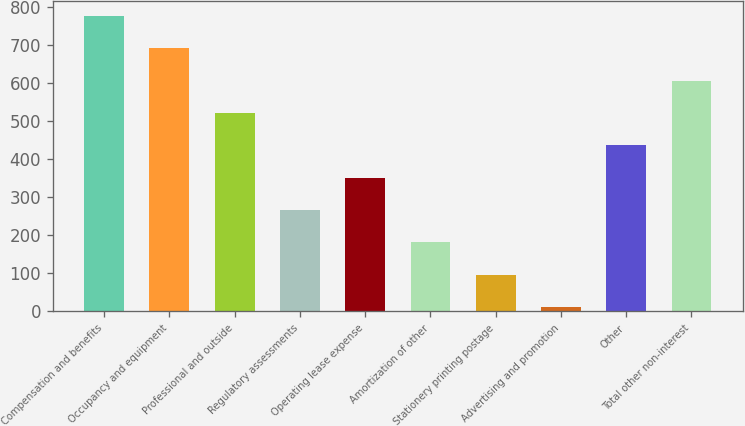Convert chart. <chart><loc_0><loc_0><loc_500><loc_500><bar_chart><fcel>Compensation and benefits<fcel>Occupancy and equipment<fcel>Professional and outside<fcel>Regulatory assessments<fcel>Operating lease expense<fcel>Amortization of other<fcel>Stationery printing postage<fcel>Advertising and promotion<fcel>Other<fcel>Total other non-interest<nl><fcel>775.74<fcel>690.88<fcel>521.16<fcel>266.58<fcel>351.44<fcel>181.72<fcel>96.86<fcel>12<fcel>436.3<fcel>606.02<nl></chart> 